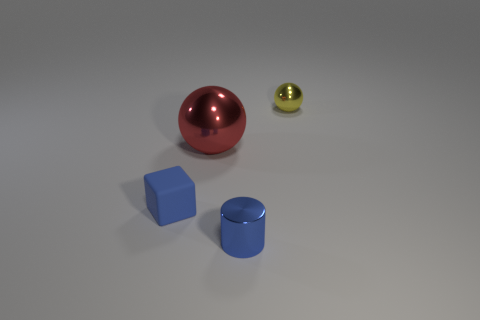Add 2 purple things. How many objects exist? 6 Subtract all cubes. How many objects are left? 3 Subtract 0 yellow blocks. How many objects are left? 4 Subtract all spheres. Subtract all shiny spheres. How many objects are left? 0 Add 1 cubes. How many cubes are left? 2 Add 1 red metallic spheres. How many red metallic spheres exist? 2 